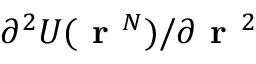<formula> <loc_0><loc_0><loc_500><loc_500>\partial ^ { 2 } U ( r ^ { N } ) / \partial r ^ { 2 }</formula> 